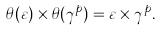<formula> <loc_0><loc_0><loc_500><loc_500>\theta ( \varepsilon ) \times \theta ( \gamma ^ { p } ) = \varepsilon \times \gamma ^ { p } .</formula> 